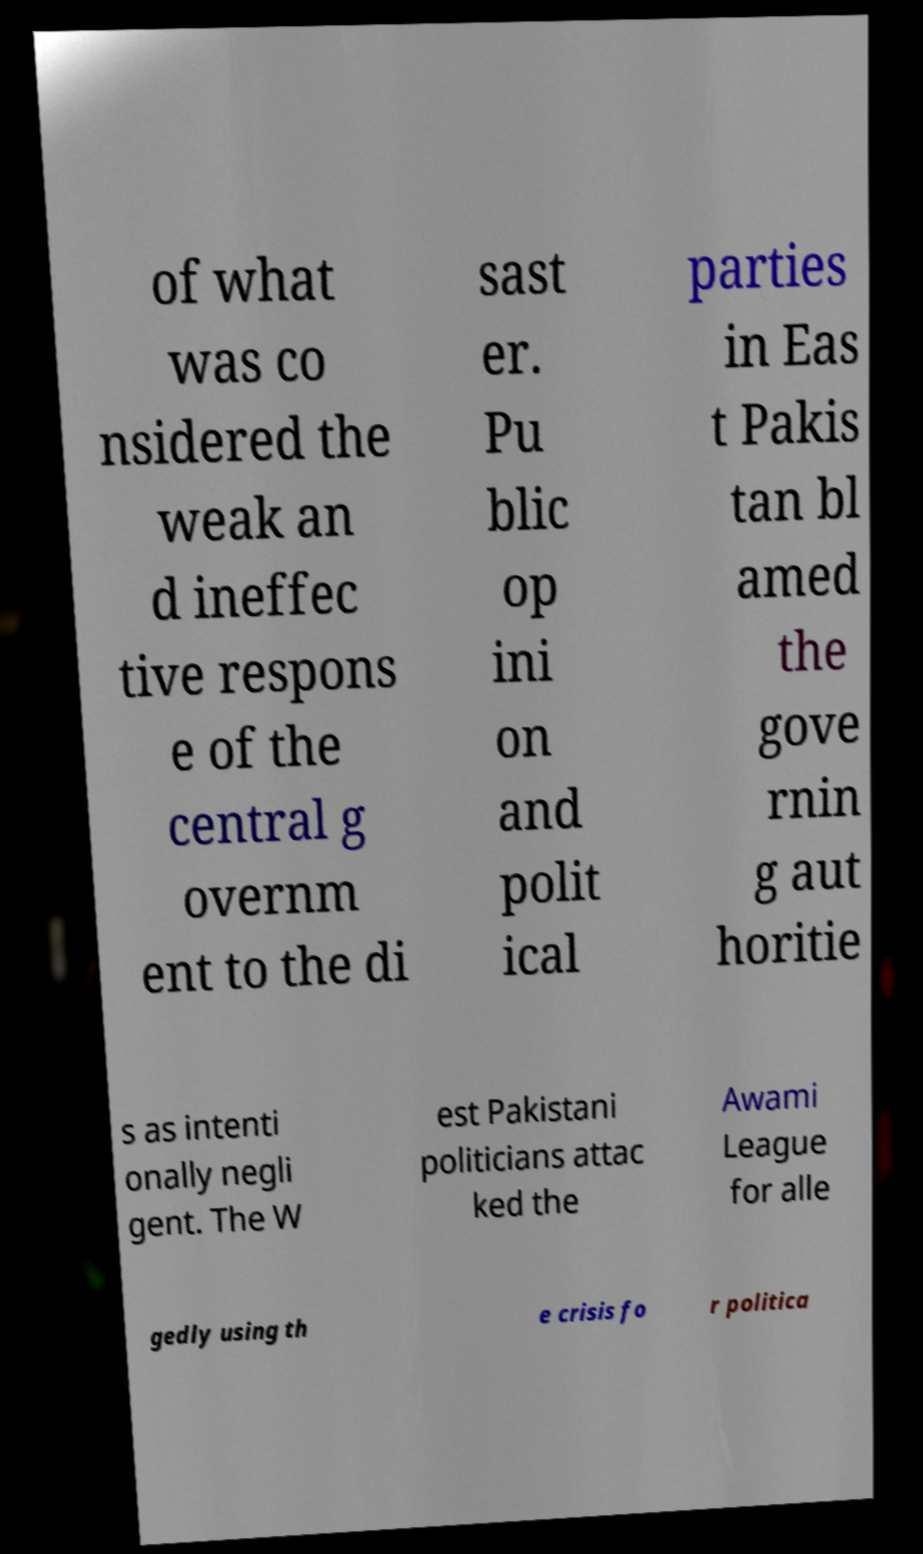Could you assist in decoding the text presented in this image and type it out clearly? of what was co nsidered the weak an d ineffec tive respons e of the central g overnm ent to the di sast er. Pu blic op ini on and polit ical parties in Eas t Pakis tan bl amed the gove rnin g aut horitie s as intenti onally negli gent. The W est Pakistani politicians attac ked the Awami League for alle gedly using th e crisis fo r politica 